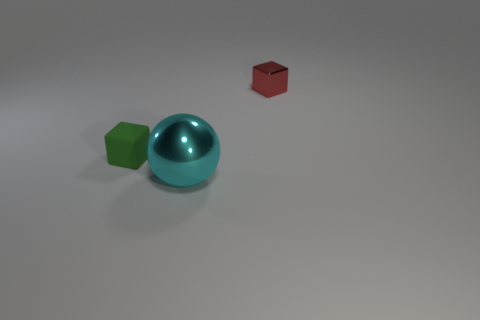Add 1 matte cylinders. How many objects exist? 4 Subtract all spheres. How many objects are left? 2 Subtract 0 red spheres. How many objects are left? 3 Subtract all large blue blocks. Subtract all tiny red shiny cubes. How many objects are left? 2 Add 2 tiny red metallic cubes. How many tiny red metallic cubes are left? 3 Add 2 blue rubber cubes. How many blue rubber cubes exist? 2 